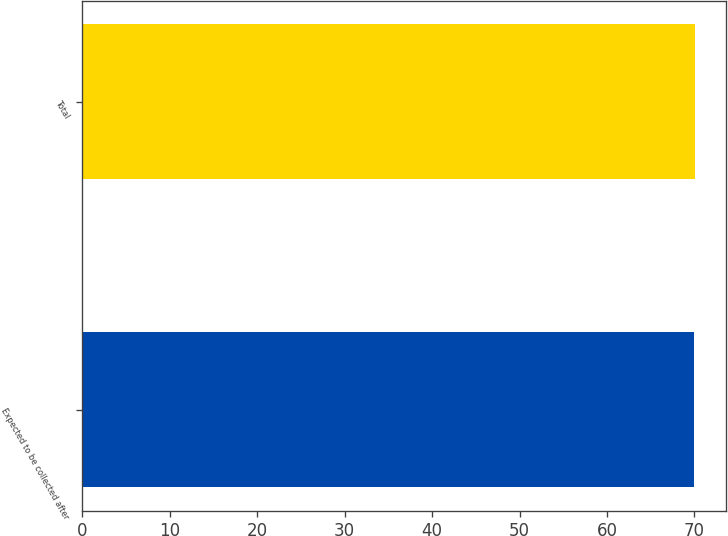<chart> <loc_0><loc_0><loc_500><loc_500><bar_chart><fcel>Expected to be collected after<fcel>Total<nl><fcel>70<fcel>70.1<nl></chart> 